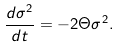<formula> <loc_0><loc_0><loc_500><loc_500>\frac { d \sigma ^ { 2 } } { d t } = - 2 \Theta \sigma ^ { 2 } .</formula> 